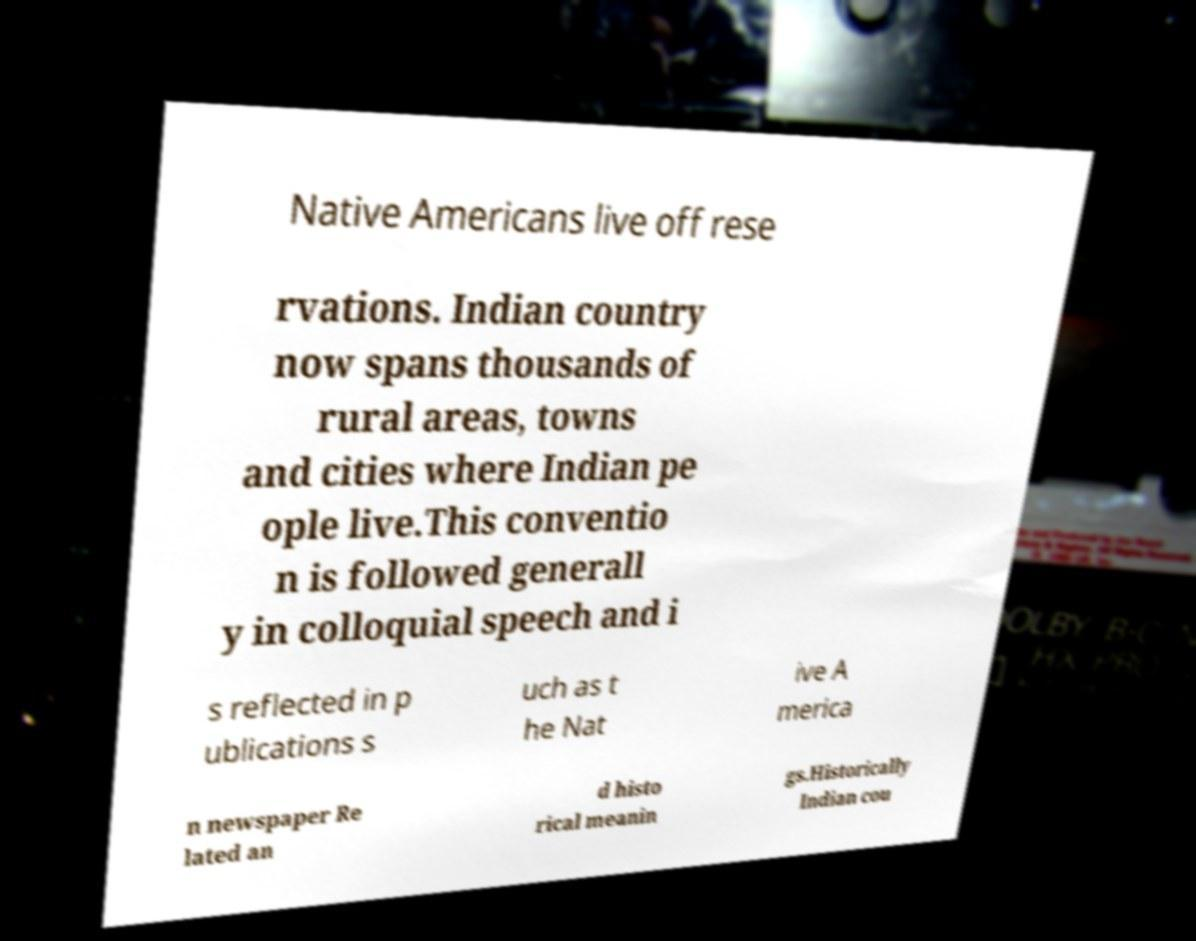There's text embedded in this image that I need extracted. Can you transcribe it verbatim? Native Americans live off rese rvations. Indian country now spans thousands of rural areas, towns and cities where Indian pe ople live.This conventio n is followed generall y in colloquial speech and i s reflected in p ublications s uch as t he Nat ive A merica n newspaper Re lated an d histo rical meanin gs.Historically Indian cou 